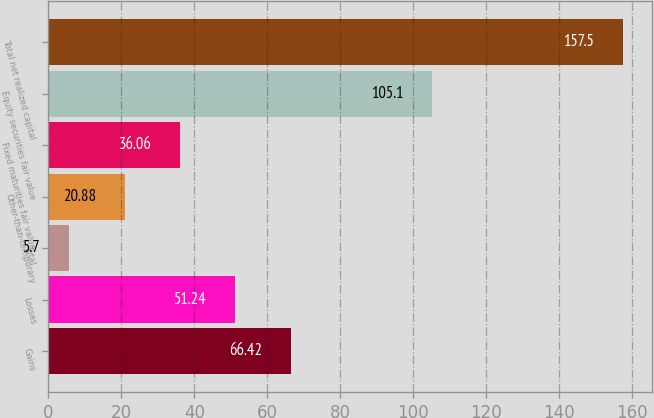<chart> <loc_0><loc_0><loc_500><loc_500><bar_chart><fcel>Gains<fcel>Losses<fcel>Total<fcel>Other-than-temporary<fcel>Fixed maturities fair value<fcel>Equity securities fair value<fcel>Total net realized capital<nl><fcel>66.42<fcel>51.24<fcel>5.7<fcel>20.88<fcel>36.06<fcel>105.1<fcel>157.5<nl></chart> 